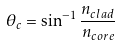<formula> <loc_0><loc_0><loc_500><loc_500>\theta _ { c } = \sin ^ { - 1 } { \frac { n _ { c l a d } } { n _ { c o r e } } }</formula> 